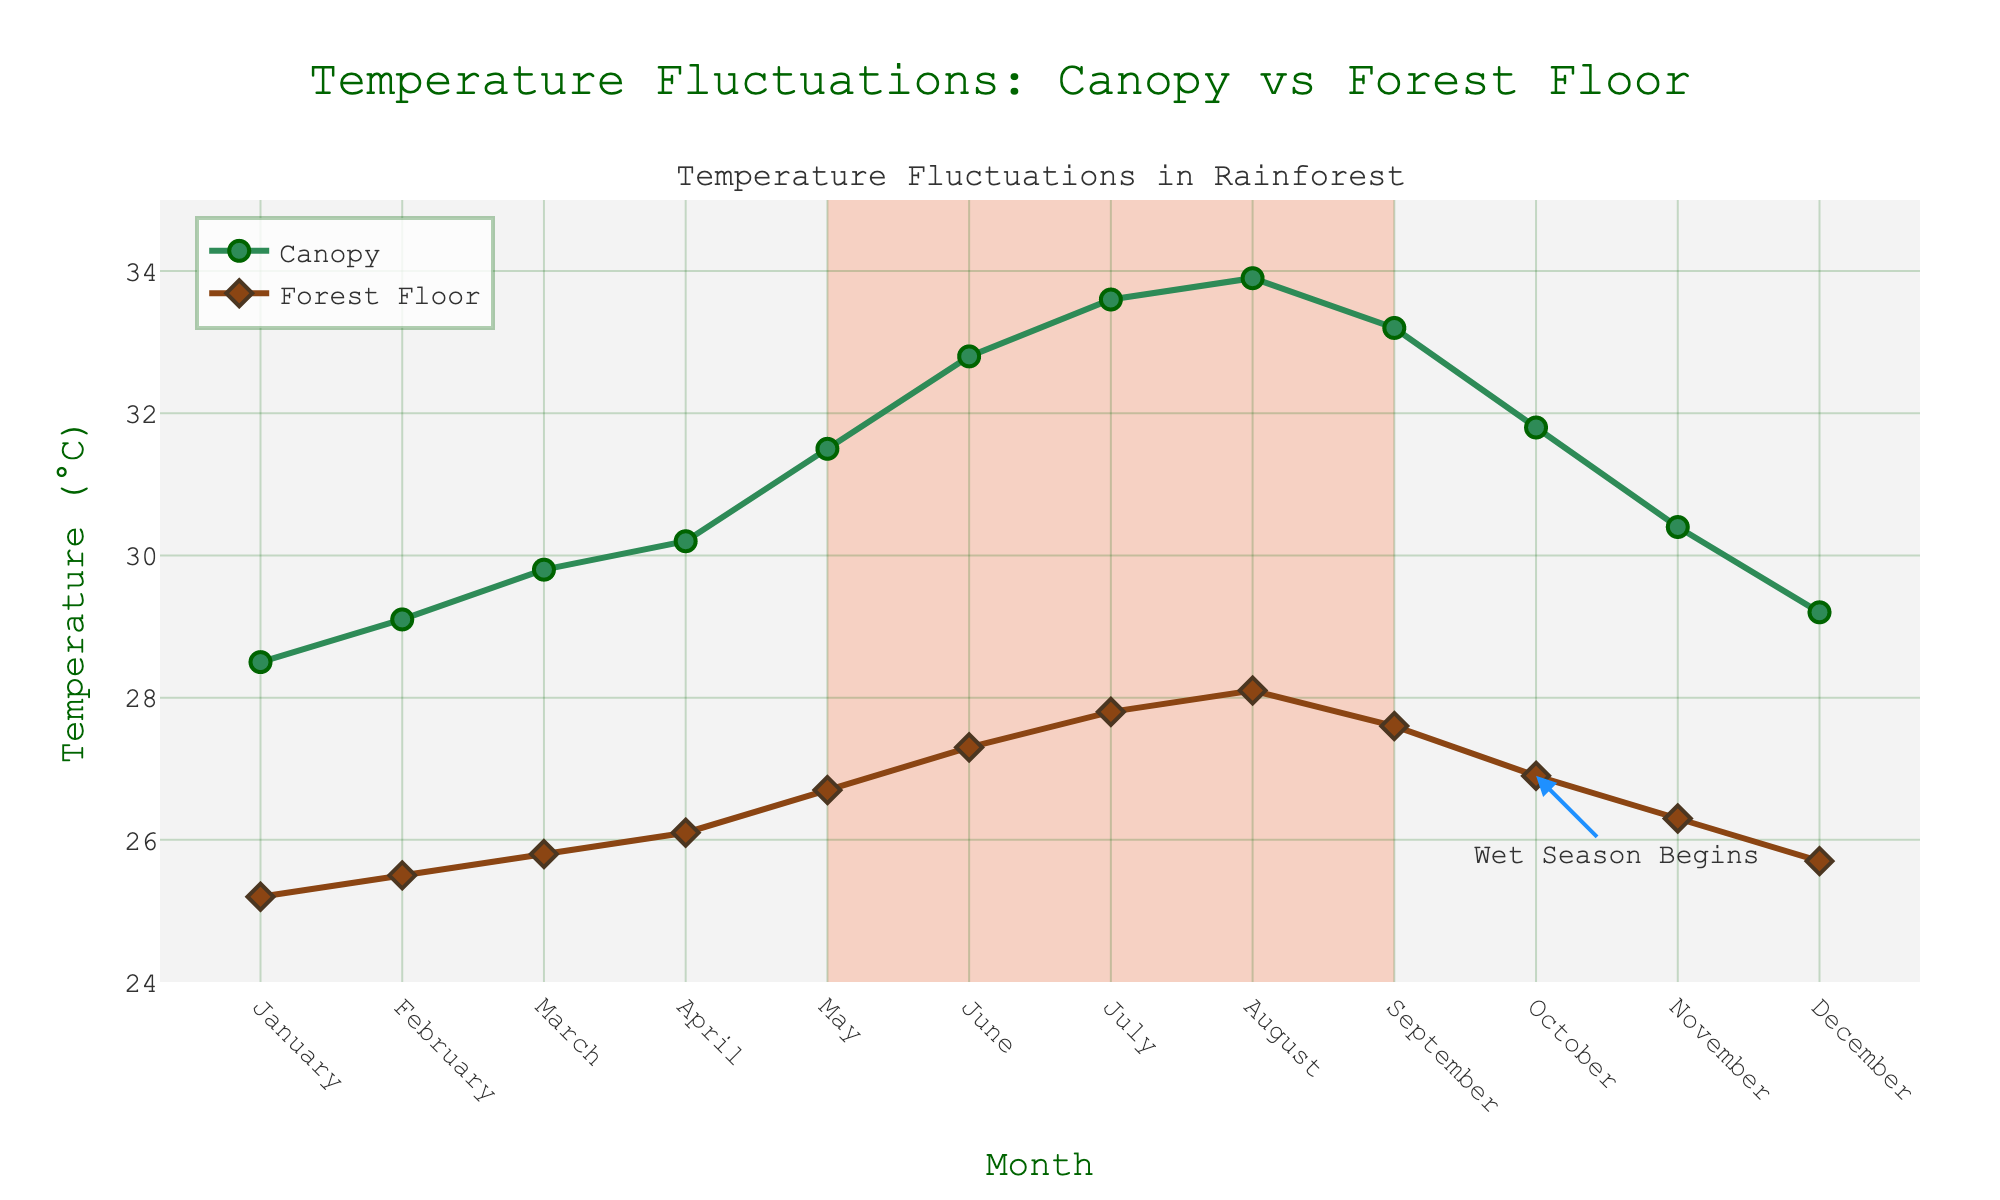Which season shows higher average temperatures in the canopy? To find the average temperature for both the wet and dry seasons, sum the temperatures in each season and divide by the number of months. The wet season canopy temperatures are 28.5, 29.1, 29.8, 30.2, 31.8, 30.4, and 29.2. The dry season canopy temperatures are 31.5, 32.8, 33.6, 33.9, and 33.2. Calculate the average for each season and compare.
Answer: Dry season How much greater is the canopy temperature compared to the floor temperature on average in the dry season? Calculate the difference for each month in the dry season (May to September) and then average these differences. Differences are (31.5-26.7), (32.8-27.3), (33.6-27.8), (33.9-28.1), and (33.2-27.6). Sum these differences and divide by 5.
Answer: 5.7°C During which month is the temperature difference between the canopy and the forest floor the smallest? Subtract the floor temperature from the canopy temperature for each month and find the month with the smallest result. Difference values are calculated for each month and the minimum is identified.
Answer: March Which month shows the highest canopy temperature? Visually identify the month where the canopy temperature line reaches its peak height on the plot.
Answer: August Does the forest floor temperature ever exceed 30°C? Look at the forest floor temperature line on the chart and check if it ever goes above the 30°C mark.
Answer: No In which month does the wet season begin, and what is the forest floor temperature at that time? Look for the annotation text indicating the start of the wet season and note the forest floor temperature at this point.
Answer: October, 26.9°C By how many degrees does the canopy temperature increase from January to its peak in August? Identify the canopy temperatures in January and August and subtract the January temperature from the August temperature (33.9 - 28.5).
Answer: 5.4°C Which season exhibits a larger temperature range for the canopy? Calculate the range (difference between maximum and minimum temperatures) for the canopy in each season and compare. The wet season range and dry season range are calculated separately.
Answer: Dry season Is there a month in which the forest floor temperature remains constant, and if so, what is that temperature? Check the floor temperature against previous and next months to see if it remains unchanged. Identify such months if they exist.
Answer: February, 25.5°C What trend can be observed in the canopy temperatures as the dry season progresses? Describe the canopy temperature pattern from May through September based on visual change in height across these months.
Answer: Increasing trend 